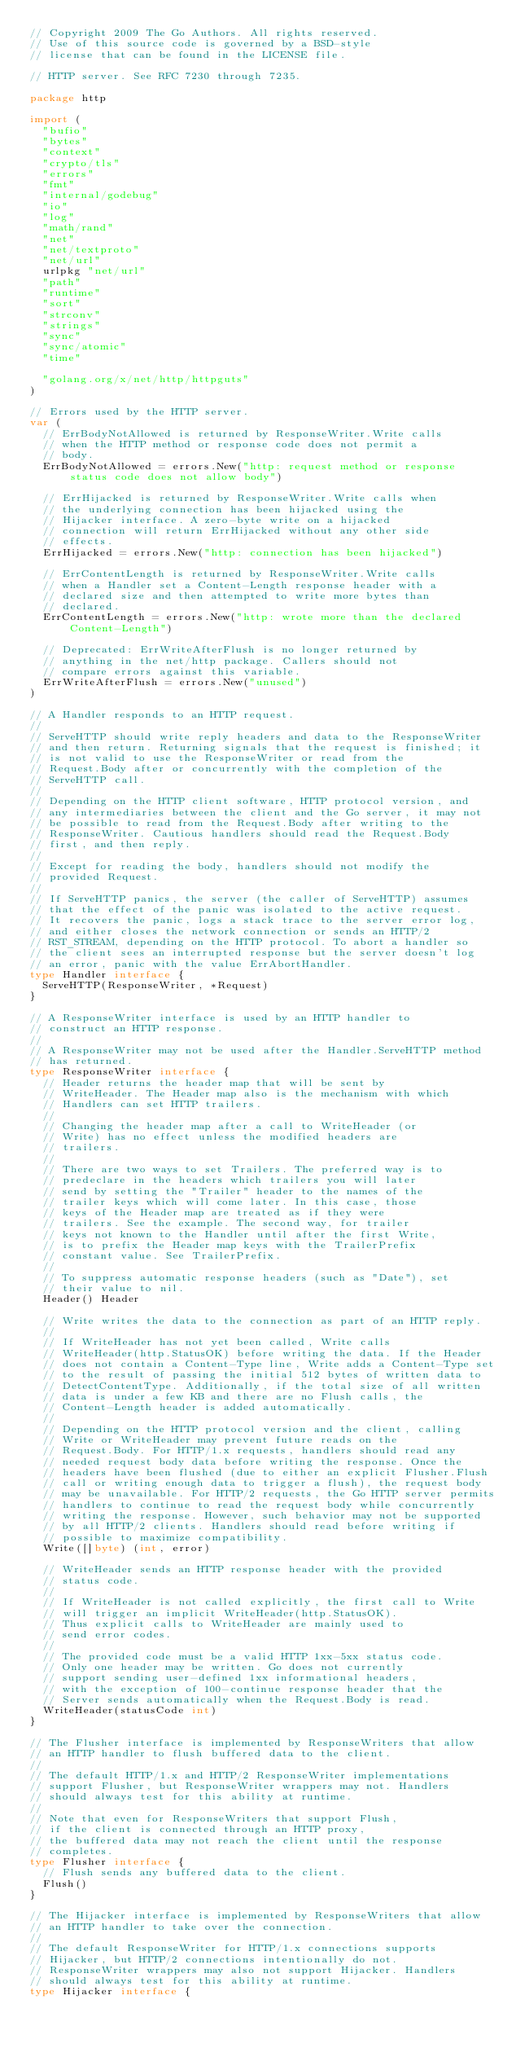<code> <loc_0><loc_0><loc_500><loc_500><_Go_>// Copyright 2009 The Go Authors. All rights reserved.
// Use of this source code is governed by a BSD-style
// license that can be found in the LICENSE file.

// HTTP server. See RFC 7230 through 7235.

package http

import (
	"bufio"
	"bytes"
	"context"
	"crypto/tls"
	"errors"
	"fmt"
	"internal/godebug"
	"io"
	"log"
	"math/rand"
	"net"
	"net/textproto"
	"net/url"
	urlpkg "net/url"
	"path"
	"runtime"
	"sort"
	"strconv"
	"strings"
	"sync"
	"sync/atomic"
	"time"

	"golang.org/x/net/http/httpguts"
)

// Errors used by the HTTP server.
var (
	// ErrBodyNotAllowed is returned by ResponseWriter.Write calls
	// when the HTTP method or response code does not permit a
	// body.
	ErrBodyNotAllowed = errors.New("http: request method or response status code does not allow body")

	// ErrHijacked is returned by ResponseWriter.Write calls when
	// the underlying connection has been hijacked using the
	// Hijacker interface. A zero-byte write on a hijacked
	// connection will return ErrHijacked without any other side
	// effects.
	ErrHijacked = errors.New("http: connection has been hijacked")

	// ErrContentLength is returned by ResponseWriter.Write calls
	// when a Handler set a Content-Length response header with a
	// declared size and then attempted to write more bytes than
	// declared.
	ErrContentLength = errors.New("http: wrote more than the declared Content-Length")

	// Deprecated: ErrWriteAfterFlush is no longer returned by
	// anything in the net/http package. Callers should not
	// compare errors against this variable.
	ErrWriteAfterFlush = errors.New("unused")
)

// A Handler responds to an HTTP request.
//
// ServeHTTP should write reply headers and data to the ResponseWriter
// and then return. Returning signals that the request is finished; it
// is not valid to use the ResponseWriter or read from the
// Request.Body after or concurrently with the completion of the
// ServeHTTP call.
//
// Depending on the HTTP client software, HTTP protocol version, and
// any intermediaries between the client and the Go server, it may not
// be possible to read from the Request.Body after writing to the
// ResponseWriter. Cautious handlers should read the Request.Body
// first, and then reply.
//
// Except for reading the body, handlers should not modify the
// provided Request.
//
// If ServeHTTP panics, the server (the caller of ServeHTTP) assumes
// that the effect of the panic was isolated to the active request.
// It recovers the panic, logs a stack trace to the server error log,
// and either closes the network connection or sends an HTTP/2
// RST_STREAM, depending on the HTTP protocol. To abort a handler so
// the client sees an interrupted response but the server doesn't log
// an error, panic with the value ErrAbortHandler.
type Handler interface {
	ServeHTTP(ResponseWriter, *Request)
}

// A ResponseWriter interface is used by an HTTP handler to
// construct an HTTP response.
//
// A ResponseWriter may not be used after the Handler.ServeHTTP method
// has returned.
type ResponseWriter interface {
	// Header returns the header map that will be sent by
	// WriteHeader. The Header map also is the mechanism with which
	// Handlers can set HTTP trailers.
	//
	// Changing the header map after a call to WriteHeader (or
	// Write) has no effect unless the modified headers are
	// trailers.
	//
	// There are two ways to set Trailers. The preferred way is to
	// predeclare in the headers which trailers you will later
	// send by setting the "Trailer" header to the names of the
	// trailer keys which will come later. In this case, those
	// keys of the Header map are treated as if they were
	// trailers. See the example. The second way, for trailer
	// keys not known to the Handler until after the first Write,
	// is to prefix the Header map keys with the TrailerPrefix
	// constant value. See TrailerPrefix.
	//
	// To suppress automatic response headers (such as "Date"), set
	// their value to nil.
	Header() Header

	// Write writes the data to the connection as part of an HTTP reply.
	//
	// If WriteHeader has not yet been called, Write calls
	// WriteHeader(http.StatusOK) before writing the data. If the Header
	// does not contain a Content-Type line, Write adds a Content-Type set
	// to the result of passing the initial 512 bytes of written data to
	// DetectContentType. Additionally, if the total size of all written
	// data is under a few KB and there are no Flush calls, the
	// Content-Length header is added automatically.
	//
	// Depending on the HTTP protocol version and the client, calling
	// Write or WriteHeader may prevent future reads on the
	// Request.Body. For HTTP/1.x requests, handlers should read any
	// needed request body data before writing the response. Once the
	// headers have been flushed (due to either an explicit Flusher.Flush
	// call or writing enough data to trigger a flush), the request body
	// may be unavailable. For HTTP/2 requests, the Go HTTP server permits
	// handlers to continue to read the request body while concurrently
	// writing the response. However, such behavior may not be supported
	// by all HTTP/2 clients. Handlers should read before writing if
	// possible to maximize compatibility.
	Write([]byte) (int, error)

	// WriteHeader sends an HTTP response header with the provided
	// status code.
	//
	// If WriteHeader is not called explicitly, the first call to Write
	// will trigger an implicit WriteHeader(http.StatusOK).
	// Thus explicit calls to WriteHeader are mainly used to
	// send error codes.
	//
	// The provided code must be a valid HTTP 1xx-5xx status code.
	// Only one header may be written. Go does not currently
	// support sending user-defined 1xx informational headers,
	// with the exception of 100-continue response header that the
	// Server sends automatically when the Request.Body is read.
	WriteHeader(statusCode int)
}

// The Flusher interface is implemented by ResponseWriters that allow
// an HTTP handler to flush buffered data to the client.
//
// The default HTTP/1.x and HTTP/2 ResponseWriter implementations
// support Flusher, but ResponseWriter wrappers may not. Handlers
// should always test for this ability at runtime.
//
// Note that even for ResponseWriters that support Flush,
// if the client is connected through an HTTP proxy,
// the buffered data may not reach the client until the response
// completes.
type Flusher interface {
	// Flush sends any buffered data to the client.
	Flush()
}

// The Hijacker interface is implemented by ResponseWriters that allow
// an HTTP handler to take over the connection.
//
// The default ResponseWriter for HTTP/1.x connections supports
// Hijacker, but HTTP/2 connections intentionally do not.
// ResponseWriter wrappers may also not support Hijacker. Handlers
// should always test for this ability at runtime.
type Hijacker interface {</code> 